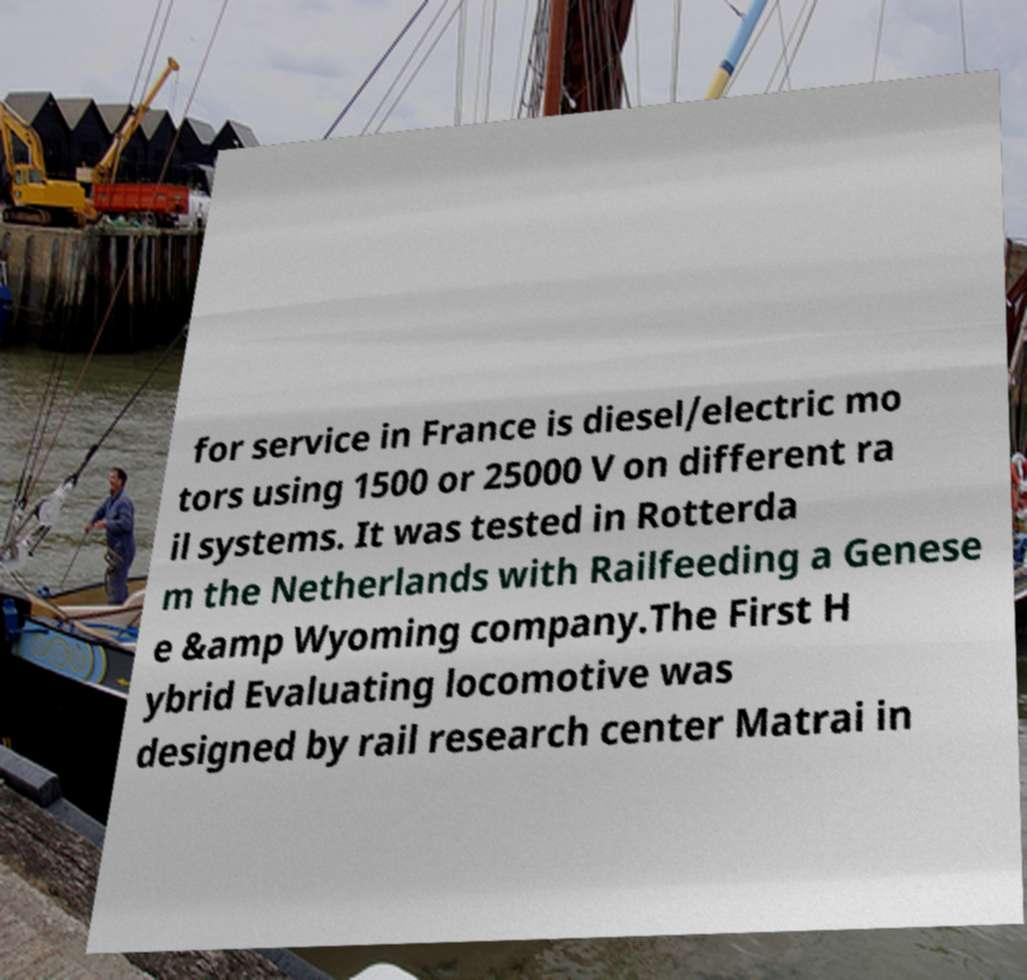For documentation purposes, I need the text within this image transcribed. Could you provide that? for service in France is diesel/electric mo tors using 1500 or 25000 V on different ra il systems. It was tested in Rotterda m the Netherlands with Railfeeding a Genese e &amp Wyoming company.The First H ybrid Evaluating locomotive was designed by rail research center Matrai in 